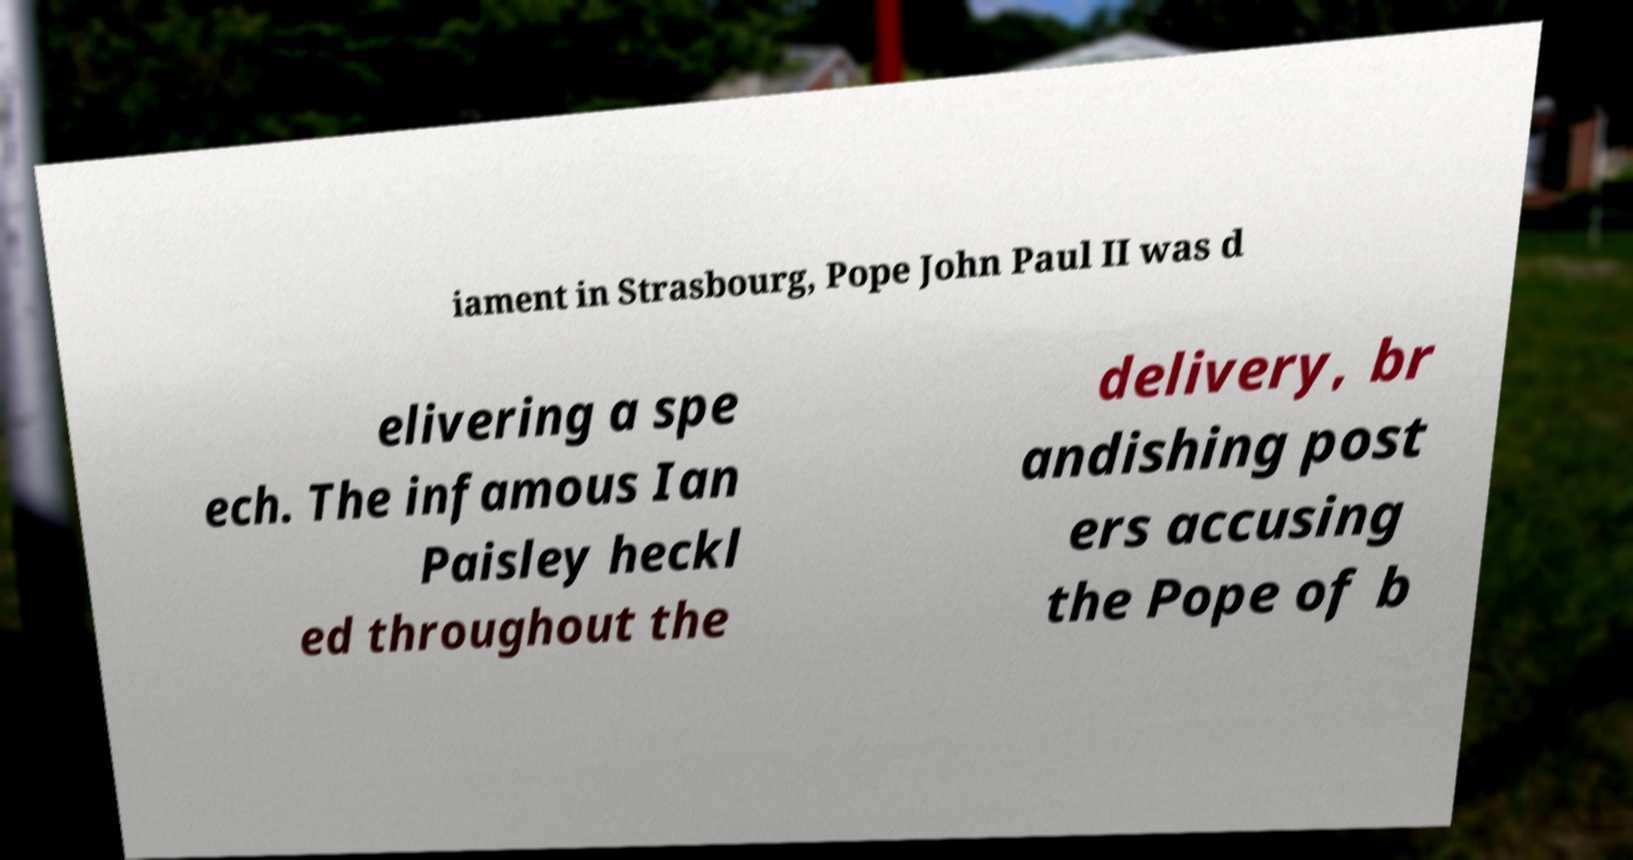I need the written content from this picture converted into text. Can you do that? iament in Strasbourg, Pope John Paul II was d elivering a spe ech. The infamous Ian Paisley heckl ed throughout the delivery, br andishing post ers accusing the Pope of b 